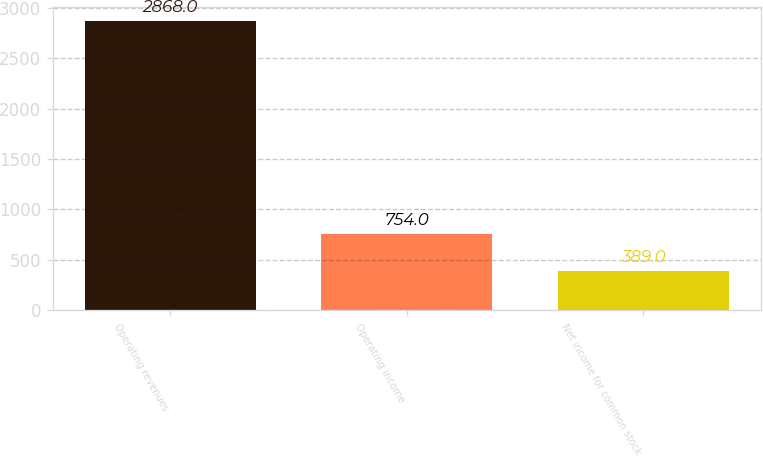Convert chart to OTSL. <chart><loc_0><loc_0><loc_500><loc_500><bar_chart><fcel>Operating revenues<fcel>Operating income<fcel>Net income for common stock<nl><fcel>2868<fcel>754<fcel>389<nl></chart> 